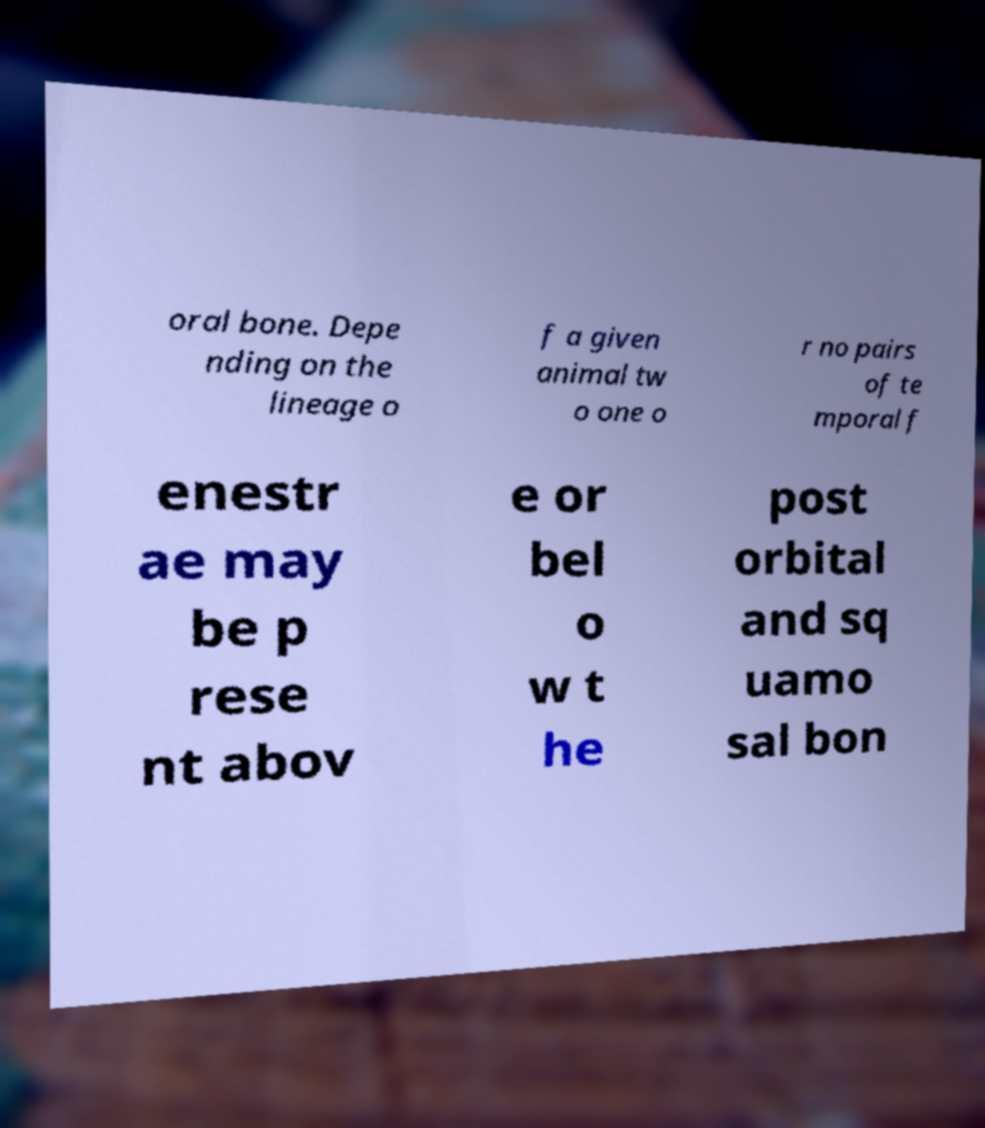There's text embedded in this image that I need extracted. Can you transcribe it verbatim? oral bone. Depe nding on the lineage o f a given animal tw o one o r no pairs of te mporal f enestr ae may be p rese nt abov e or bel o w t he post orbital and sq uamo sal bon 